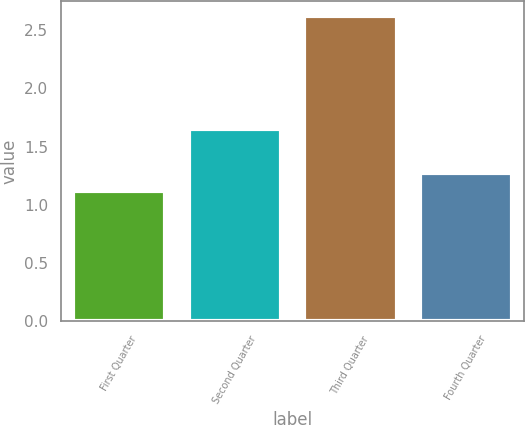Convert chart to OTSL. <chart><loc_0><loc_0><loc_500><loc_500><bar_chart><fcel>First Quarter<fcel>Second Quarter<fcel>Third Quarter<fcel>Fourth Quarter<nl><fcel>1.12<fcel>1.65<fcel>2.62<fcel>1.27<nl></chart> 